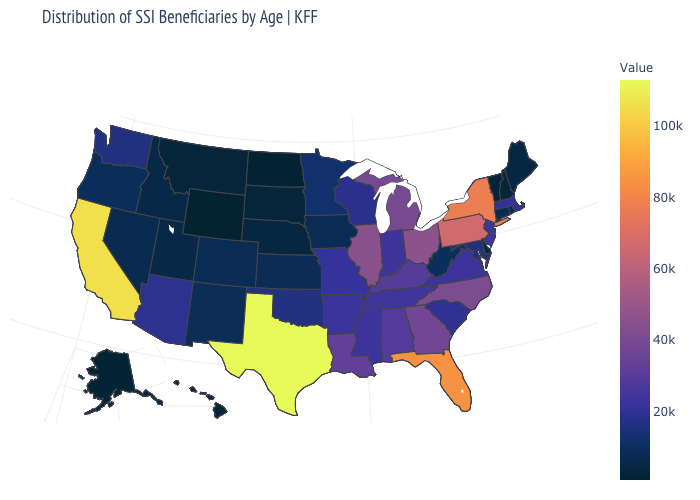Which states hav the highest value in the West?
Answer briefly. California. Does Kentucky have a higher value than Florida?
Give a very brief answer. No. Does Texas have the highest value in the USA?
Keep it brief. Yes. Which states have the lowest value in the USA?
Short answer required. Wyoming. 